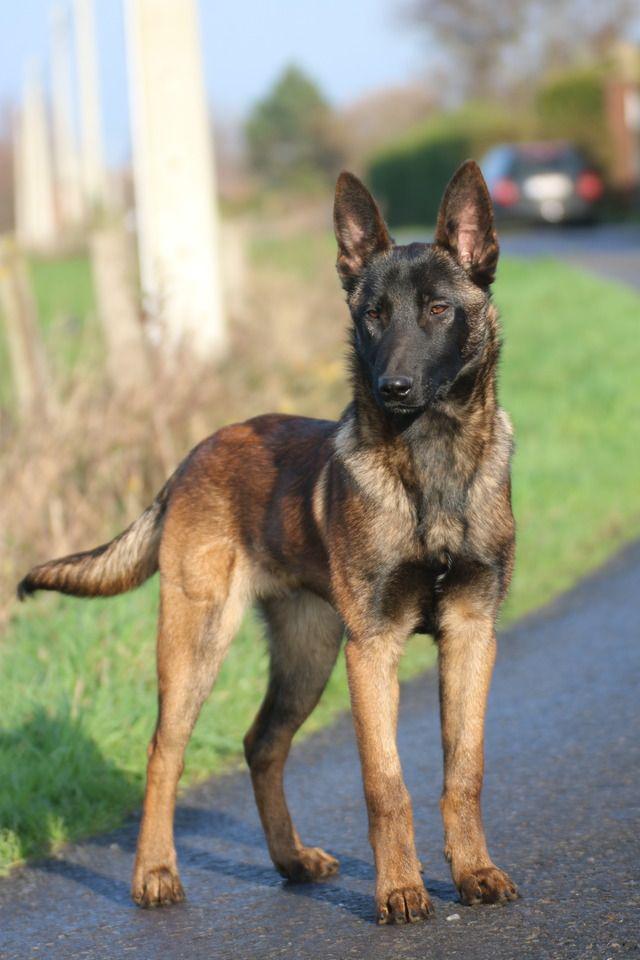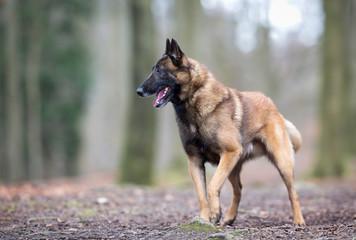The first image is the image on the left, the second image is the image on the right. Assess this claim about the two images: "One dog stands and looks directly towards camera.". Correct or not? Answer yes or no. Yes. 